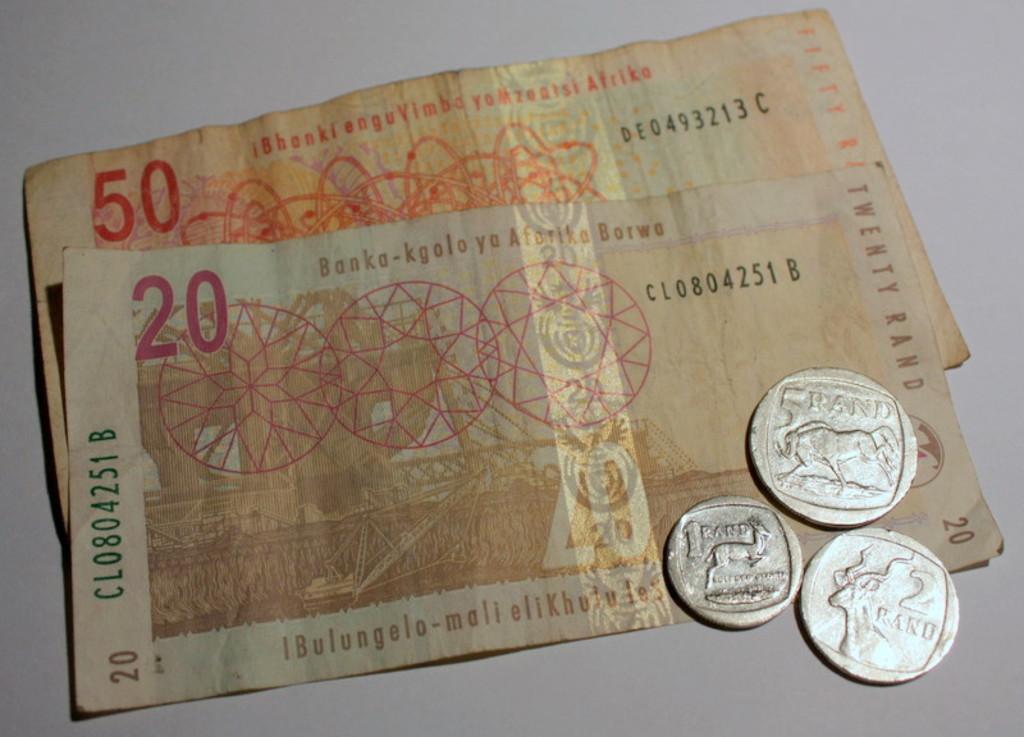Please provide a concise description of this image. In the image we can see there are 50 and 20 rupees note and three silver coins kept on the table. 